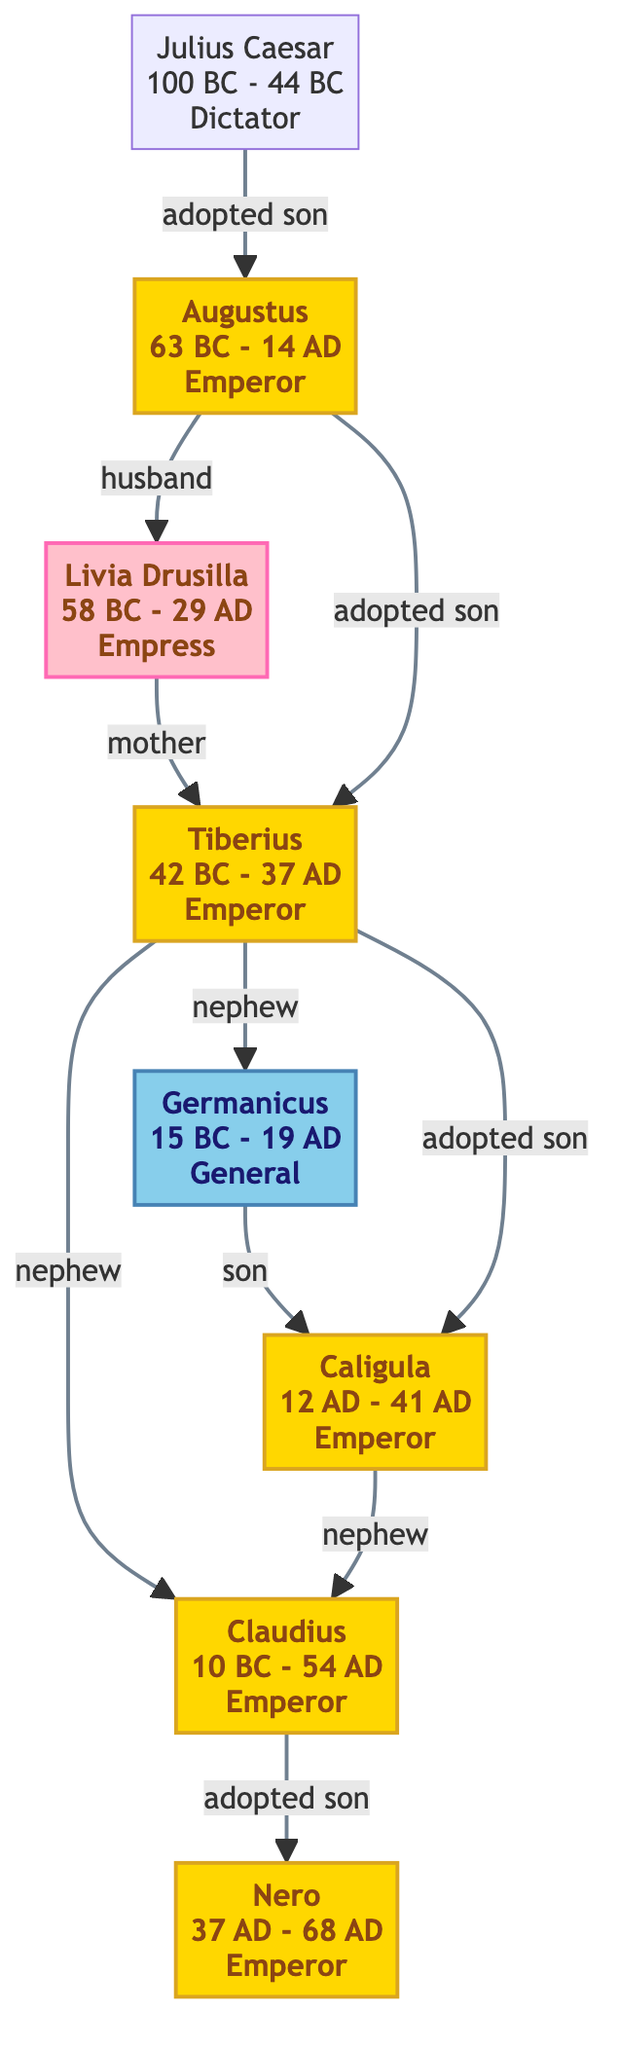What is the title of Julius Caesar? The diagram indicates that Julius Caesar held the title of "Dictator," which is explicitly stated in his node details.
Answer: Dictator Who was Augustus' husband? The diagram shows that Augustus' wife was Livia Drusilla, as indicated by the relationship "husband" connecting Augustus to Livia in the diagram.
Answer: Livia Drusilla How many emperors are represented in the diagram? By counting the nodes highlighted with the emperor class, we find that there are five emperors: Augustus, Tiberius, Caligula, Claudius, and Nero.
Answer: 5 Who is the son of Germanicus? The diagram outlines a relationship connecting Germanicus to his son Caligula, which is clearly shown with the "son" relationship link.
Answer: Caligula Which emperor is known as the adopted son of Tiberius? The diagram indicates that Caligula is referred to as Tiberius' adopted son, demonstrating the connection through the specified relationship.
Answer: Caligula What relationship does Tiberius have with Germanicus? The diagram states that Tiberius is the uncle of Germanicus, as reflected by the "nephew" relationship link directed from Tiberius to Germanicus.
Answer: Nephew Which two individuals are directly linked as mother and son? The diagram shows a direct relationship between Livia Drusilla and Tiberius, with Livia labeled as Tiberius' mother in the connections.
Answer: Livia Drusilla What type of family connection exists between Nero and Claudius? The diagram specifies that Claudius is Nero's adopted father, illustrated in the relationship linking Claudius to Nero with "adopted son."
Answer: Adopted son How is Julius Caesar related to Augustus? The diagram depicts a direct relationship where Julius Caesar is described as Augustus's adopted son, showing how they are connected in lineage.
Answer: Adopted son 